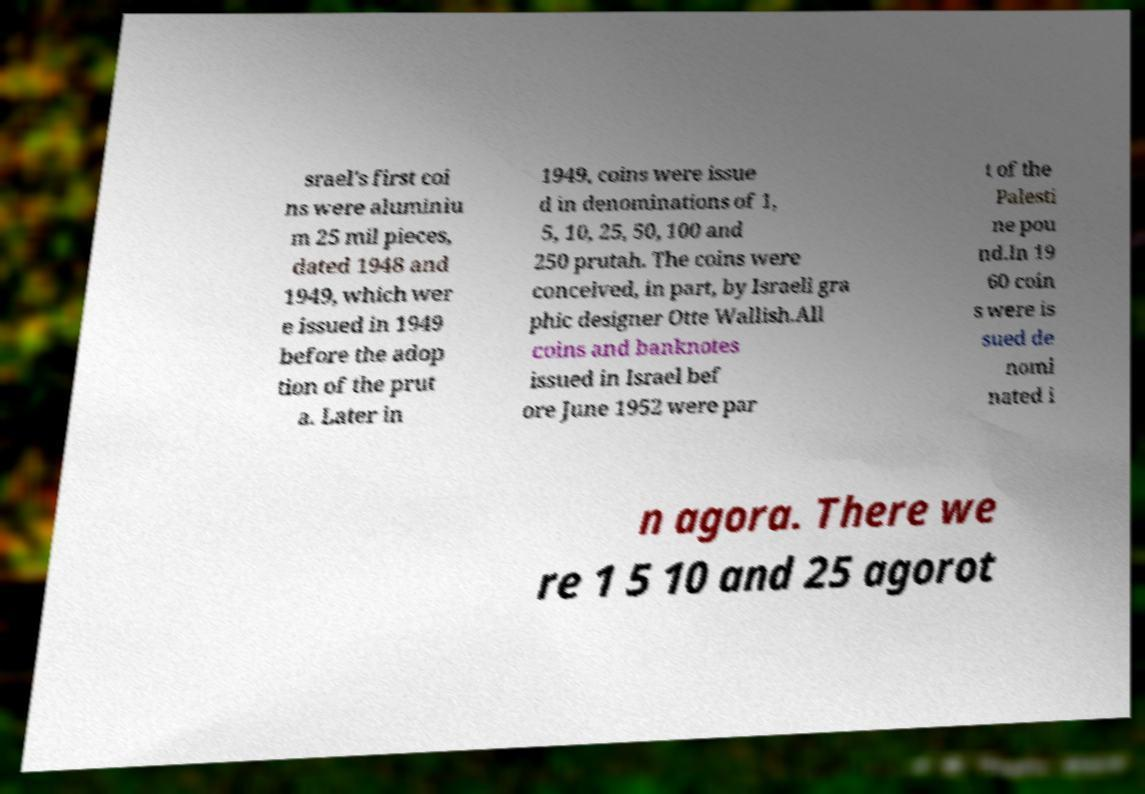Can you accurately transcribe the text from the provided image for me? srael's first coi ns were aluminiu m 25 mil pieces, dated 1948 and 1949, which wer e issued in 1949 before the adop tion of the prut a. Later in 1949, coins were issue d in denominations of 1, 5, 10, 25, 50, 100 and 250 prutah. The coins were conceived, in part, by Israeli gra phic designer Otte Wallish.All coins and banknotes issued in Israel bef ore June 1952 were par t of the Palesti ne pou nd.In 19 60 coin s were is sued de nomi nated i n agora. There we re 1 5 10 and 25 agorot 